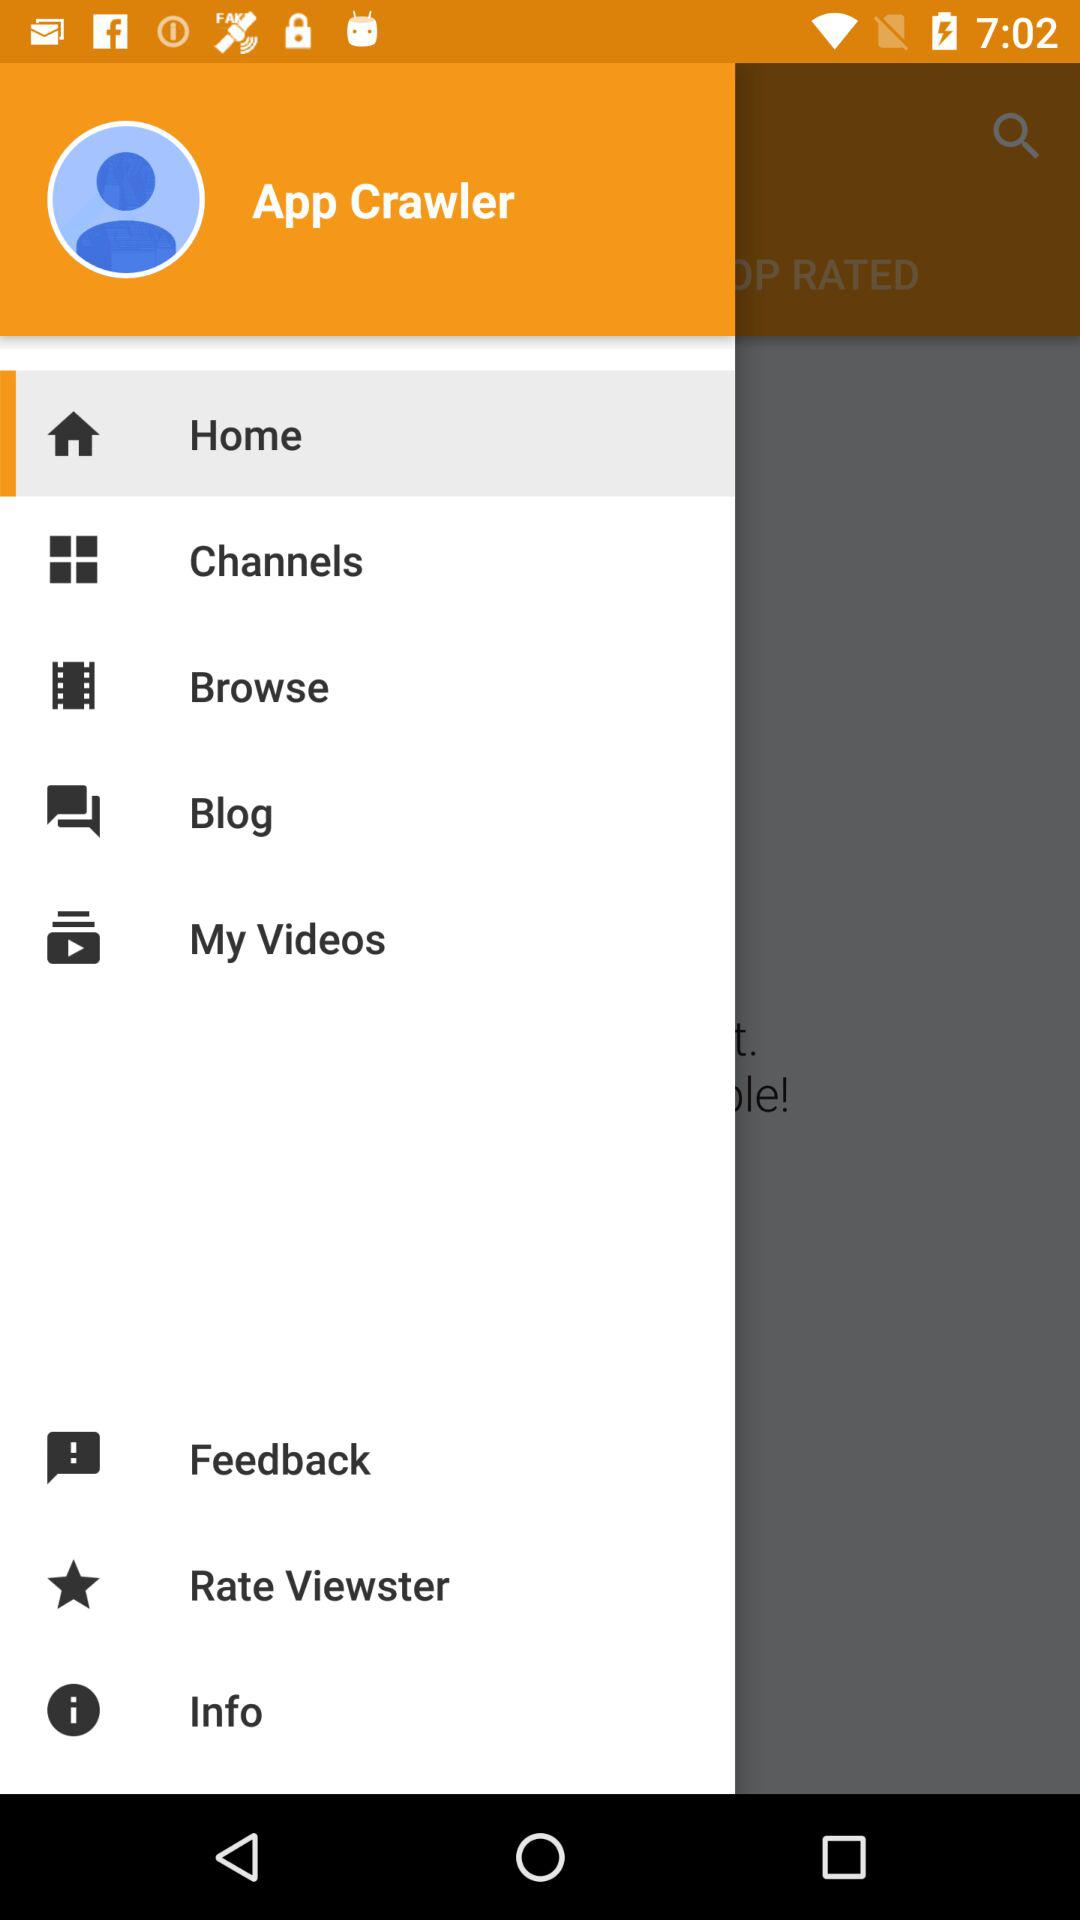What is the name of the user? The name of the user is App Crawler. 